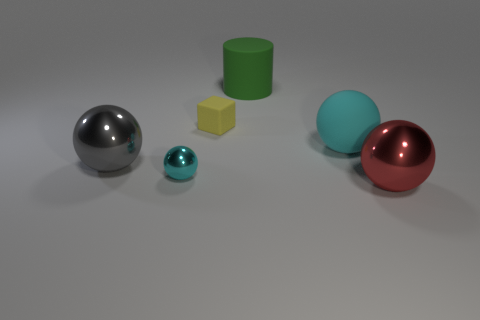Add 1 tiny purple matte blocks. How many objects exist? 7 Subtract all big balls. How many balls are left? 1 Subtract all gray spheres. Subtract all cyan cylinders. How many spheres are left? 3 Subtract all red cylinders. How many cyan balls are left? 2 Subtract all red spheres. How many spheres are left? 3 Subtract all yellow blocks. Subtract all large gray shiny balls. How many objects are left? 4 Add 1 cyan objects. How many cyan objects are left? 3 Add 5 yellow blocks. How many yellow blocks exist? 6 Subtract 0 green spheres. How many objects are left? 6 Subtract all balls. How many objects are left? 2 